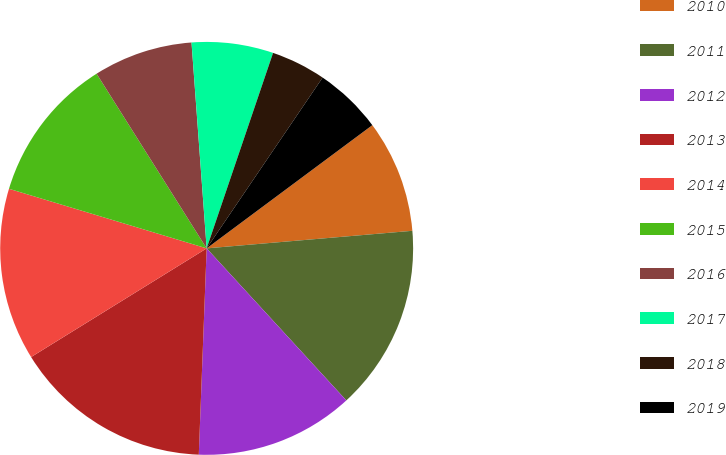Convert chart to OTSL. <chart><loc_0><loc_0><loc_500><loc_500><pie_chart><fcel>2010<fcel>2011<fcel>2012<fcel>2013<fcel>2014<fcel>2015<fcel>2016<fcel>2017<fcel>2018<fcel>2019<nl><fcel>8.82%<fcel>14.53%<fcel>12.43%<fcel>15.57%<fcel>13.48%<fcel>11.39%<fcel>7.78%<fcel>6.38%<fcel>4.28%<fcel>5.33%<nl></chart> 